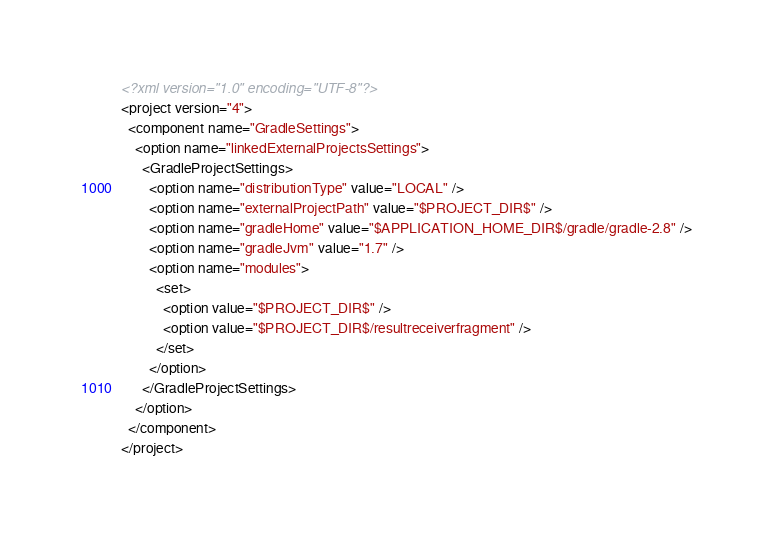Convert code to text. <code><loc_0><loc_0><loc_500><loc_500><_XML_><?xml version="1.0" encoding="UTF-8"?>
<project version="4">
  <component name="GradleSettings">
    <option name="linkedExternalProjectsSettings">
      <GradleProjectSettings>
        <option name="distributionType" value="LOCAL" />
        <option name="externalProjectPath" value="$PROJECT_DIR$" />
        <option name="gradleHome" value="$APPLICATION_HOME_DIR$/gradle/gradle-2.8" />
        <option name="gradleJvm" value="1.7" />
        <option name="modules">
          <set>
            <option value="$PROJECT_DIR$" />
            <option value="$PROJECT_DIR$/resultreceiverfragment" />
          </set>
        </option>
      </GradleProjectSettings>
    </option>
  </component>
</project></code> 